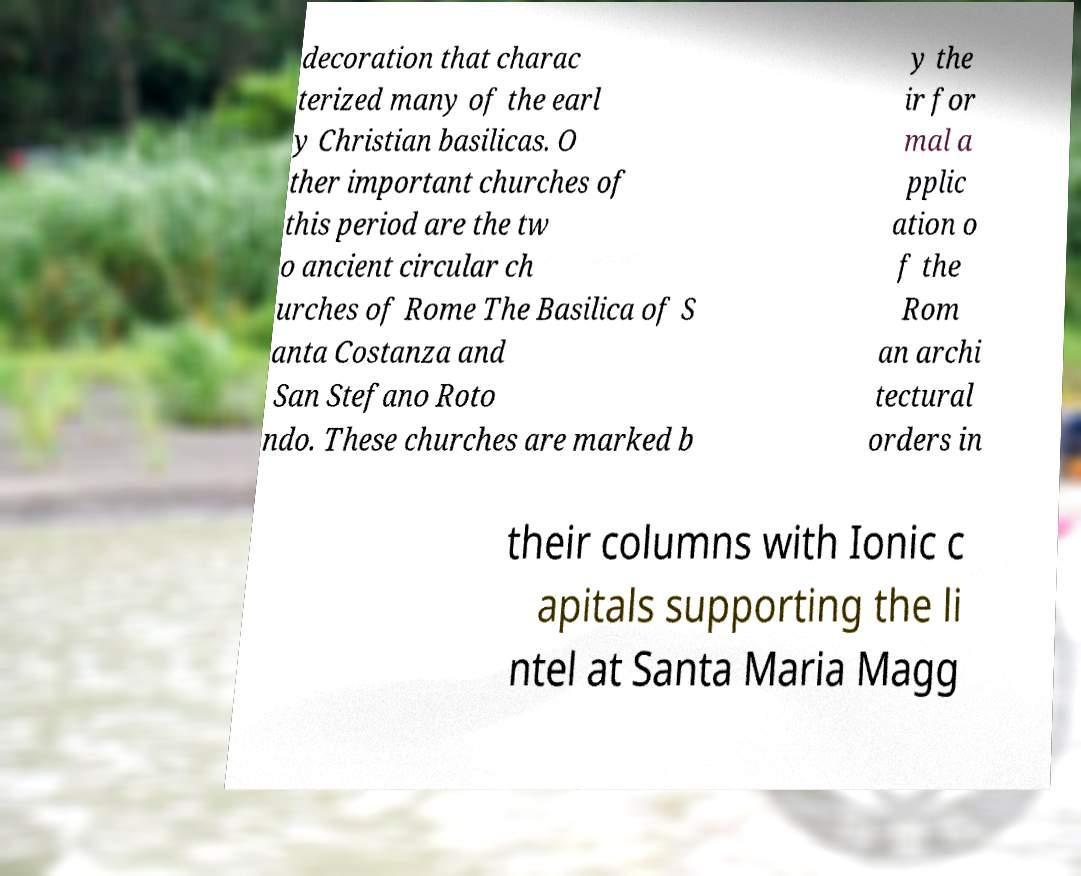For documentation purposes, I need the text within this image transcribed. Could you provide that? decoration that charac terized many of the earl y Christian basilicas. O ther important churches of this period are the tw o ancient circular ch urches of Rome The Basilica of S anta Costanza and San Stefano Roto ndo. These churches are marked b y the ir for mal a pplic ation o f the Rom an archi tectural orders in their columns with Ionic c apitals supporting the li ntel at Santa Maria Magg 